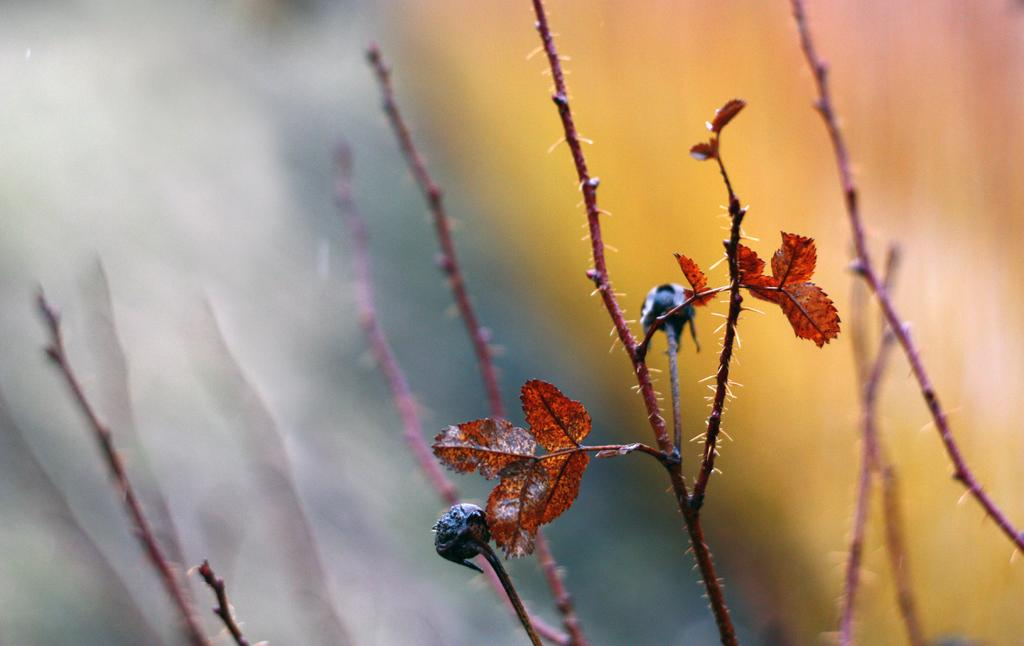What type of plant is in the image? There is a woody plant in the image. What feature of the plant can be observed? The wood has leaves. What type of crowd can be seen gathering around the plant in the image? There is no crowd present in the image; it only features the woody plant with leaves. How is the plant being used to produce milk in the image? The plant is not being used to produce milk in the image, as it is a woody plant with leaves and not a dairy-producing organism. 